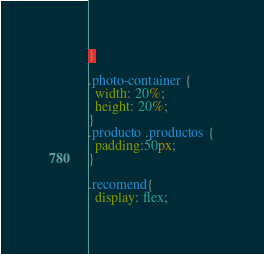Convert code to text. <code><loc_0><loc_0><loc_500><loc_500><_CSS_>
}

.photo-container {
  width: 20%;
  height: 20%;
}
.producto .productos {
  padding:50px;
}

.recomend{
  display: flex;</code> 